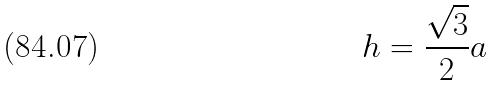Convert formula to latex. <formula><loc_0><loc_0><loc_500><loc_500>h = \frac { \sqrt { 3 } } { 2 } a</formula> 